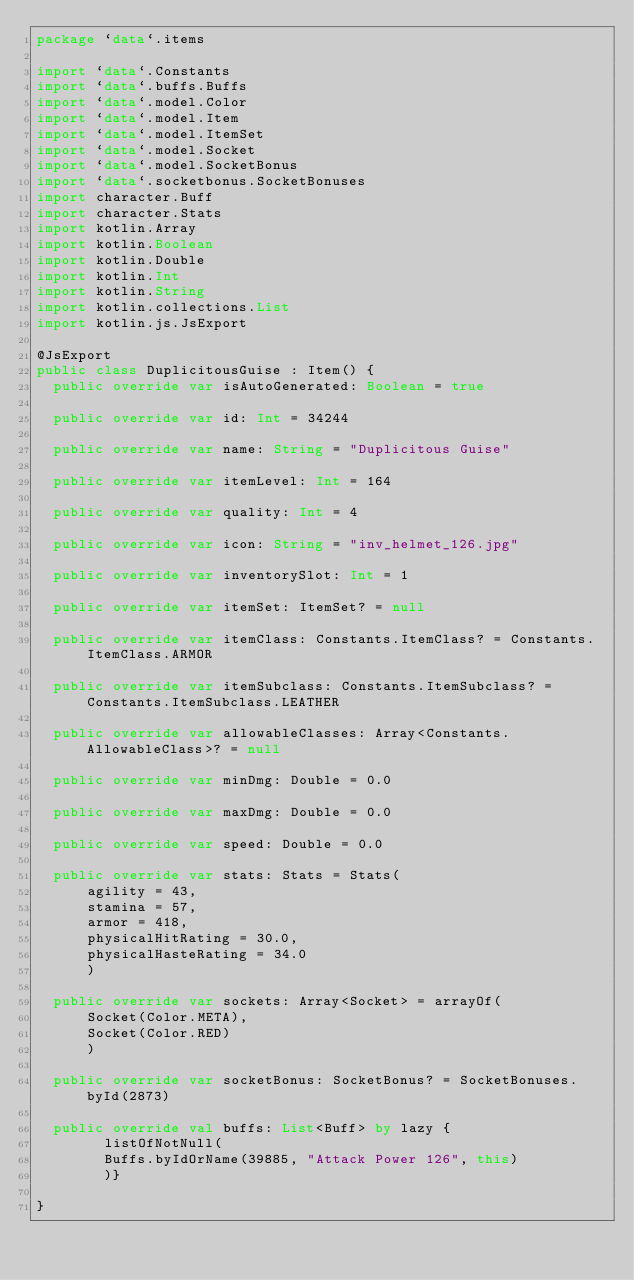Convert code to text. <code><loc_0><loc_0><loc_500><loc_500><_Kotlin_>package `data`.items

import `data`.Constants
import `data`.buffs.Buffs
import `data`.model.Color
import `data`.model.Item
import `data`.model.ItemSet
import `data`.model.Socket
import `data`.model.SocketBonus
import `data`.socketbonus.SocketBonuses
import character.Buff
import character.Stats
import kotlin.Array
import kotlin.Boolean
import kotlin.Double
import kotlin.Int
import kotlin.String
import kotlin.collections.List
import kotlin.js.JsExport

@JsExport
public class DuplicitousGuise : Item() {
  public override var isAutoGenerated: Boolean = true

  public override var id: Int = 34244

  public override var name: String = "Duplicitous Guise"

  public override var itemLevel: Int = 164

  public override var quality: Int = 4

  public override var icon: String = "inv_helmet_126.jpg"

  public override var inventorySlot: Int = 1

  public override var itemSet: ItemSet? = null

  public override var itemClass: Constants.ItemClass? = Constants.ItemClass.ARMOR

  public override var itemSubclass: Constants.ItemSubclass? = Constants.ItemSubclass.LEATHER

  public override var allowableClasses: Array<Constants.AllowableClass>? = null

  public override var minDmg: Double = 0.0

  public override var maxDmg: Double = 0.0

  public override var speed: Double = 0.0

  public override var stats: Stats = Stats(
      agility = 43,
      stamina = 57,
      armor = 418,
      physicalHitRating = 30.0,
      physicalHasteRating = 34.0
      )

  public override var sockets: Array<Socket> = arrayOf(
      Socket(Color.META),
      Socket(Color.RED)
      )

  public override var socketBonus: SocketBonus? = SocketBonuses.byId(2873)

  public override val buffs: List<Buff> by lazy {
        listOfNotNull(
        Buffs.byIdOrName(39885, "Attack Power 126", this)
        )}

}
</code> 